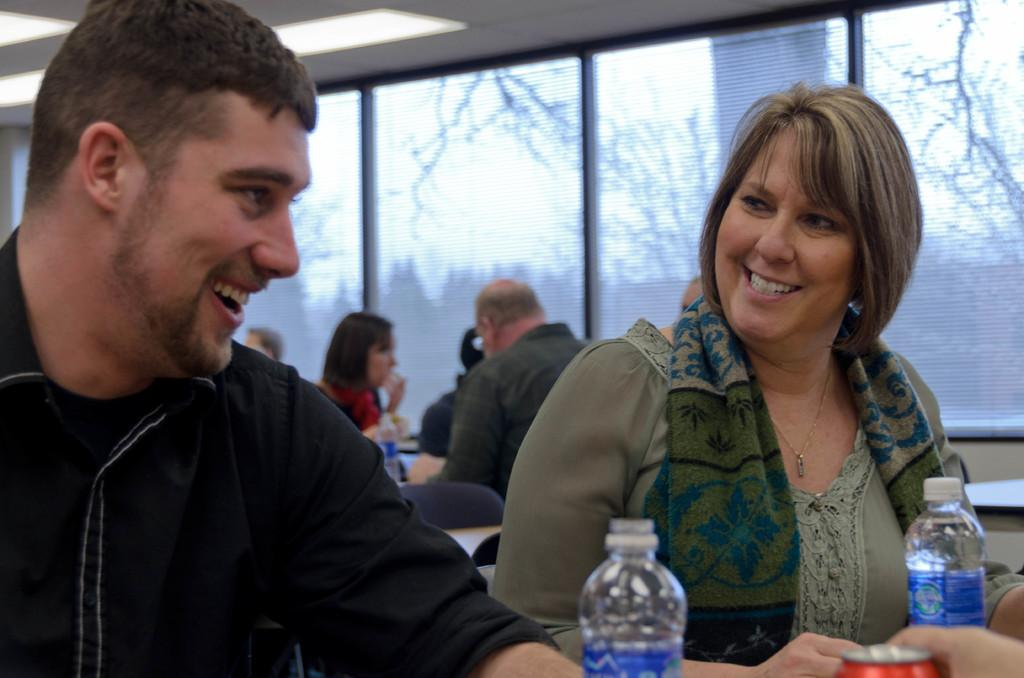Who is present in the image? There is a man and a woman in the image. What are the expressions on their faces? Both the man and the woman are smiling. What objects can be seen in the image? There is a water bottle and a tin in the image. What can be seen in the background of the image? There is a group of people sitting and trees are present in the background of the image. Are there any other objects visible in the background? Yes, there is a glass in the background of the image. What type of drum is being played by the man in the image? There is no drum present in the image; the man is not playing any musical instrument. 